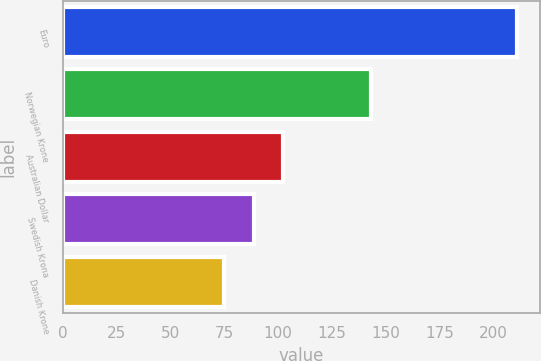Convert chart. <chart><loc_0><loc_0><loc_500><loc_500><bar_chart><fcel>Euro<fcel>Norwegian Krone<fcel>Australian Dollar<fcel>Swedish Krona<fcel>Danish Krone<nl><fcel>211<fcel>143<fcel>102.2<fcel>88.6<fcel>75<nl></chart> 